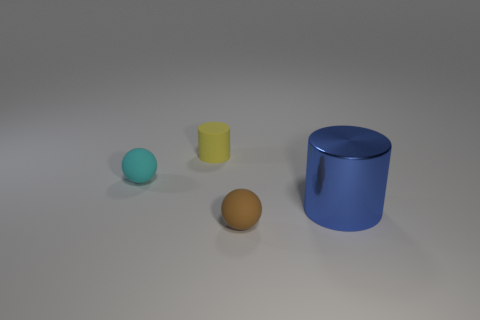Subtract 1 balls. How many balls are left? 1 Subtract all brown balls. How many balls are left? 1 Subtract 1 yellow cylinders. How many objects are left? 3 Subtract all purple balls. Subtract all brown cylinders. How many balls are left? 2 Subtract all green balls. How many blue cylinders are left? 1 Subtract all large gray blocks. Subtract all large blue cylinders. How many objects are left? 3 Add 3 small cylinders. How many small cylinders are left? 4 Add 1 brown things. How many brown things exist? 2 Add 1 small cyan matte objects. How many objects exist? 5 